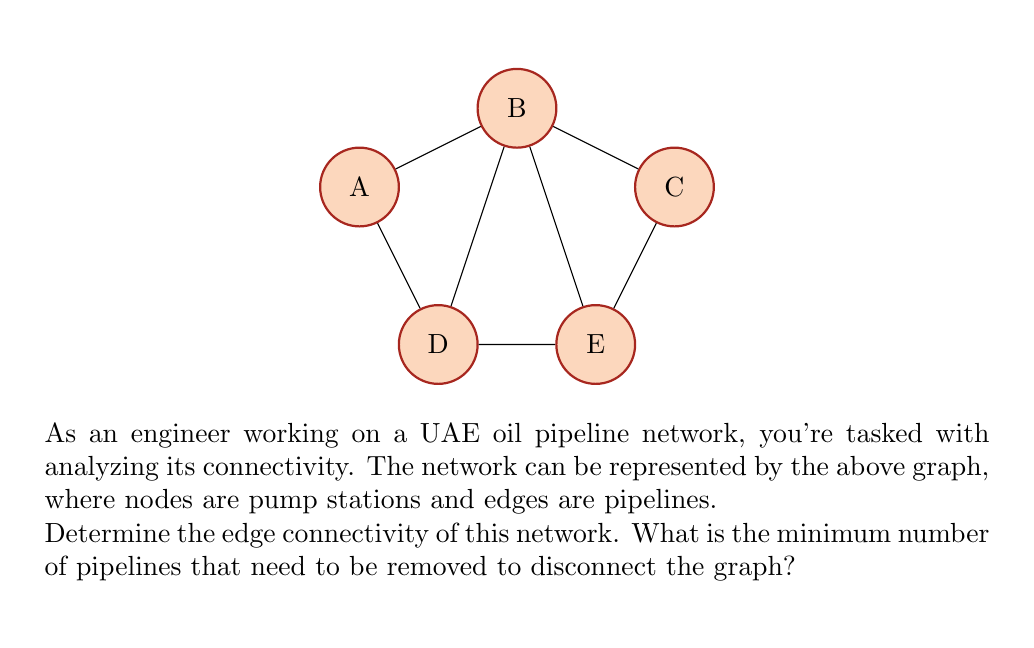Could you help me with this problem? To solve this problem, we need to understand the concept of edge connectivity in graph theory:

1) Edge connectivity is the minimum number of edges that need to be removed to disconnect a graph.

2) We can find this by examining all possible cuts in the graph and identifying the smallest one.

3) Let's analyze potential cuts:

   a) Removing edges connected to node A: We need to remove 2 edges (A-B and A-D).
   b) Removing edges connected to node B: We need to remove 4 edges (B-A, B-C, B-D, B-E).
   c) Removing edges connected to node C: We need to remove 2 edges (C-B and C-E).
   d) Removing edges connected to node D: We need to remove 3 edges (D-A, D-B, D-E).
   e) Removing edges connected to node E: We need to remove 3 edges (E-B, E-C, E-D).

4) The smallest cut we found involves removing 2 edges.

5) We can verify that removing any 2 edges will not disconnect the graph unless they are the specific pairs (A-B and A-D) or (C-B and C-E).

6) Therefore, the edge connectivity of this graph is 2.

This means that the UAE oil pipeline network represented by this graph requires at least 2 pipelines to be removed to disconnect it, making it relatively vulnerable to disruptions.
Answer: 2 